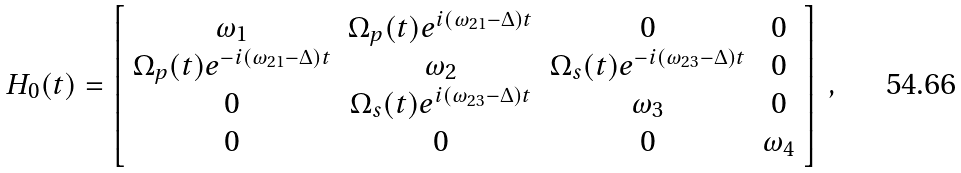<formula> <loc_0><loc_0><loc_500><loc_500>H _ { 0 } ( t ) = \left [ \begin{array} { c c c c } \omega _ { 1 } & \Omega _ { p } ( t ) e ^ { i ( \omega _ { 2 1 } - \Delta ) t } & 0 & 0 \\ \Omega _ { p } ( t ) e ^ { - i ( \omega _ { 2 1 } - \Delta ) t } & \omega _ { 2 } & \Omega _ { s } ( t ) e ^ { - i ( \omega _ { 2 3 } - \Delta ) t } & 0 \\ 0 & \Omega _ { s } ( t ) e ^ { i ( \omega _ { 2 3 } - \Delta ) t } & \omega _ { 3 } & 0 \\ 0 & 0 & 0 & \omega _ { 4 } \\ \end{array} \right ] \, ,</formula> 